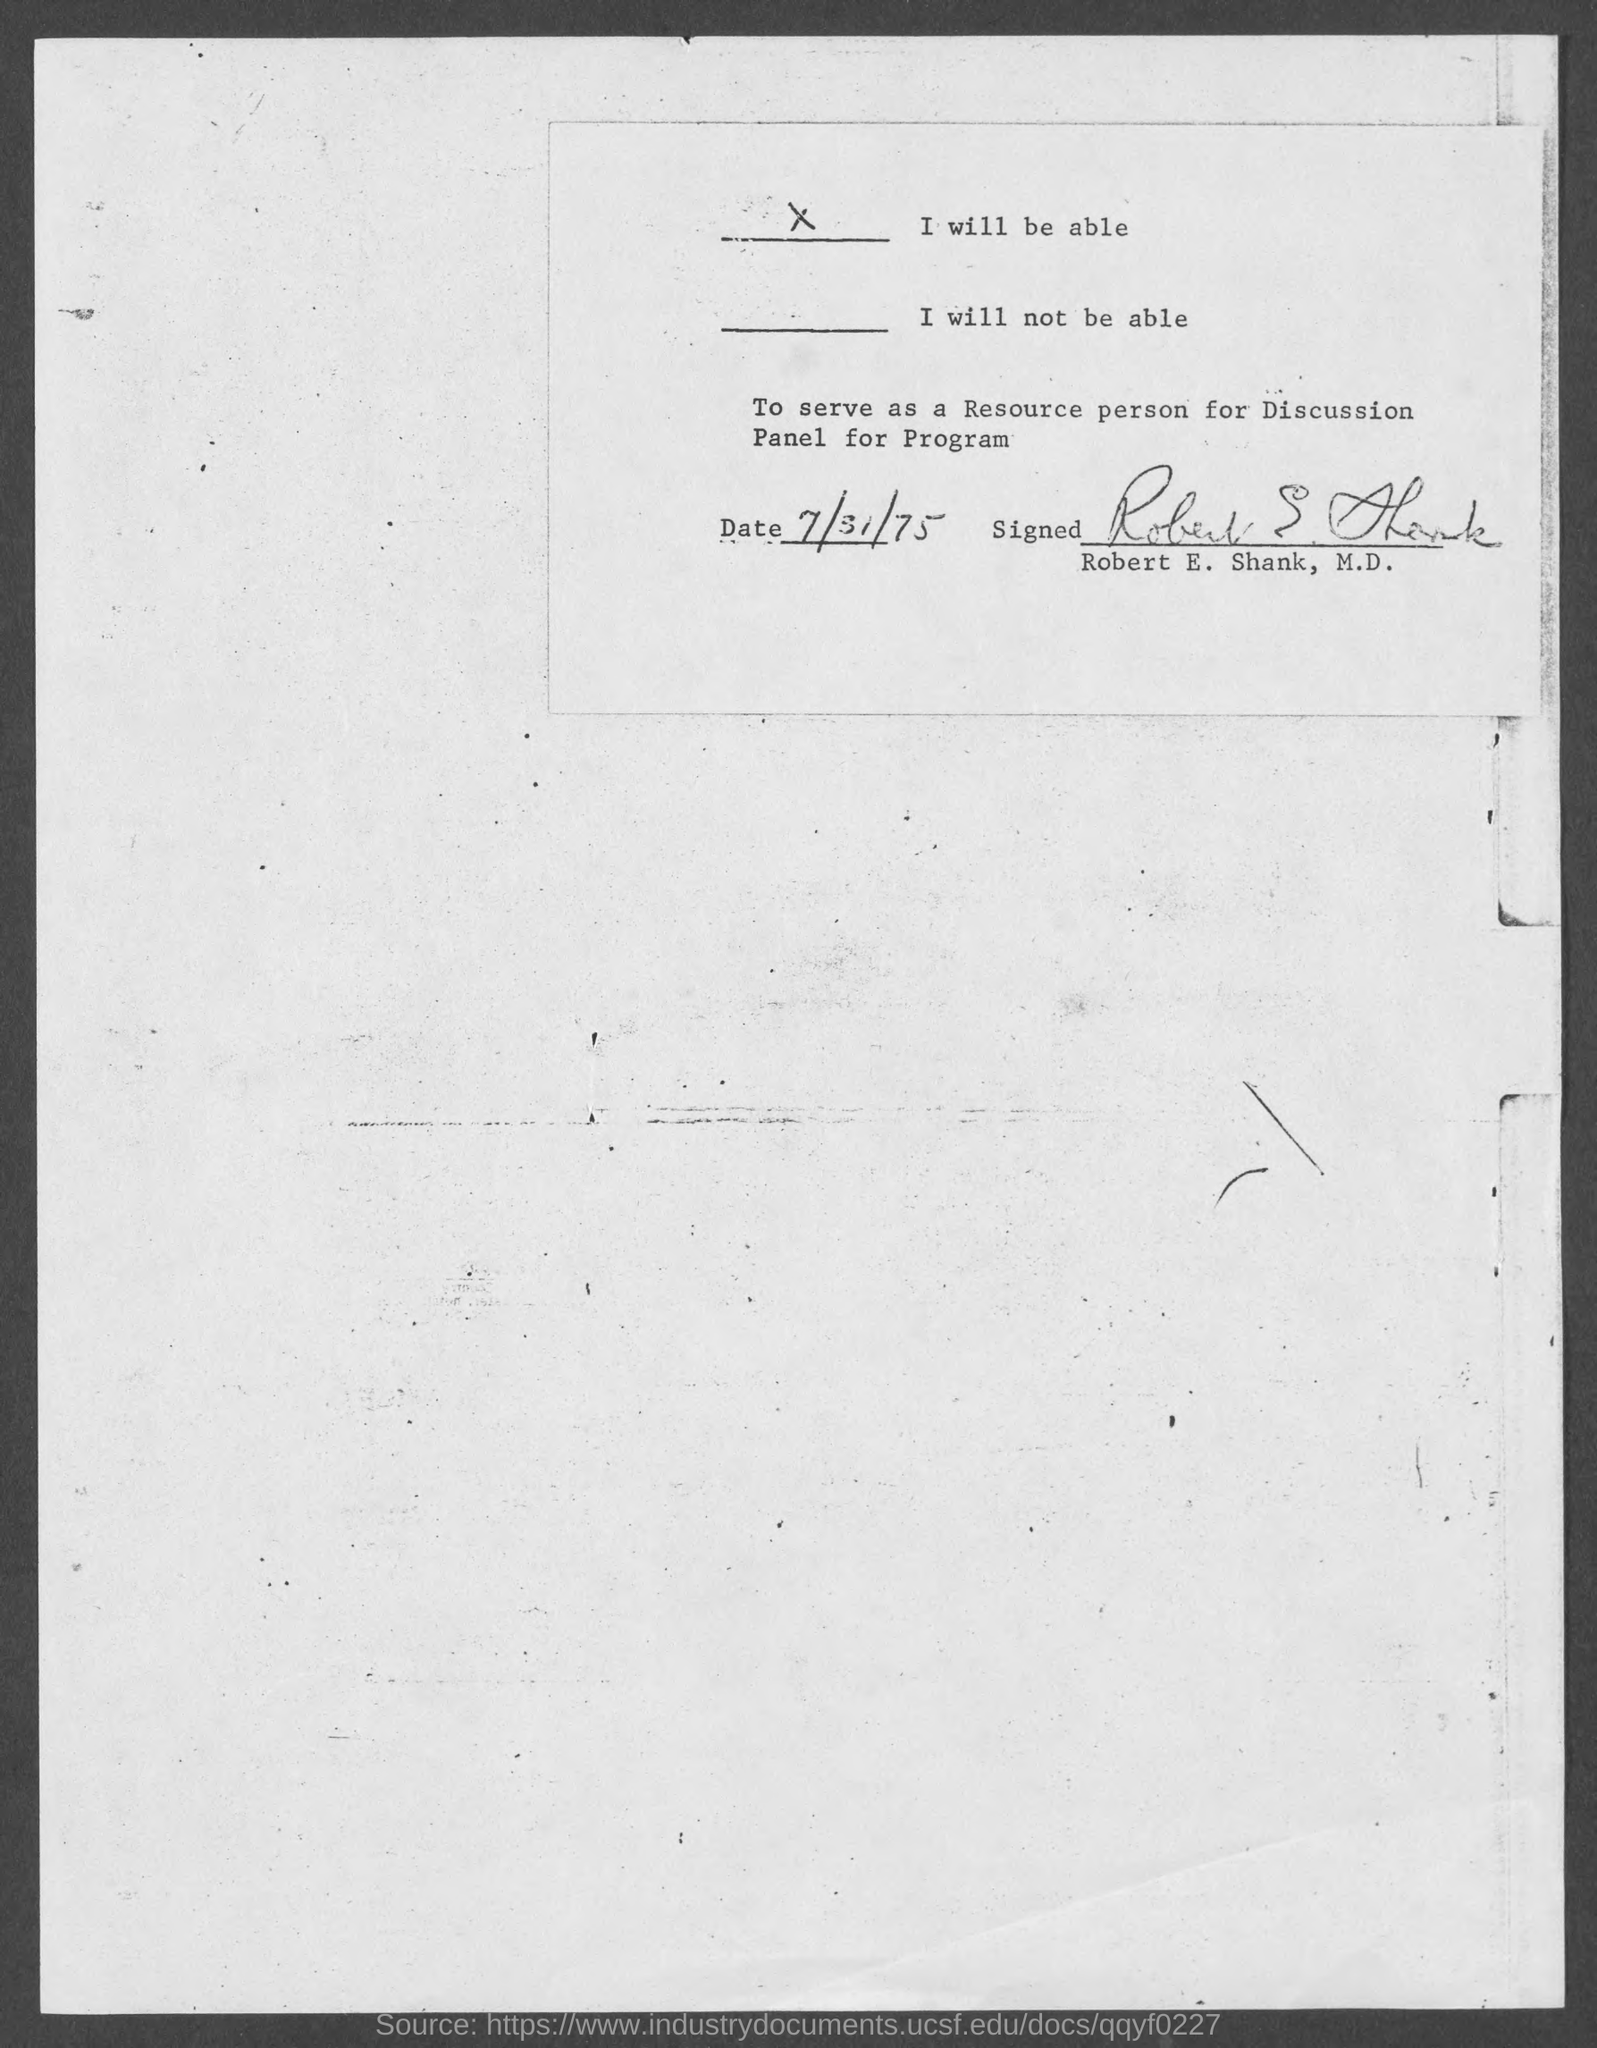Draw attention to some important aspects in this diagram. Robert E. Shank has been selected to serve as a panelist for the discussion program. 